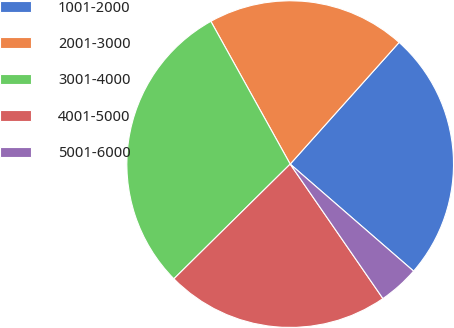<chart> <loc_0><loc_0><loc_500><loc_500><pie_chart><fcel>1001-2000<fcel>2001-3000<fcel>3001-4000<fcel>4001-5000<fcel>5001-6000<nl><fcel>24.75%<fcel>19.69%<fcel>29.32%<fcel>22.22%<fcel>4.02%<nl></chart> 